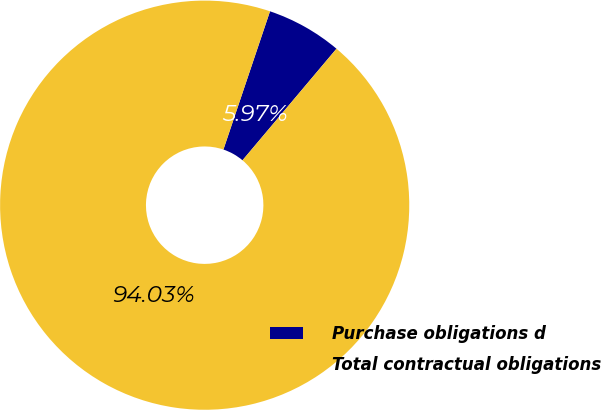Convert chart. <chart><loc_0><loc_0><loc_500><loc_500><pie_chart><fcel>Purchase obligations d<fcel>Total contractual obligations<nl><fcel>5.97%<fcel>94.03%<nl></chart> 